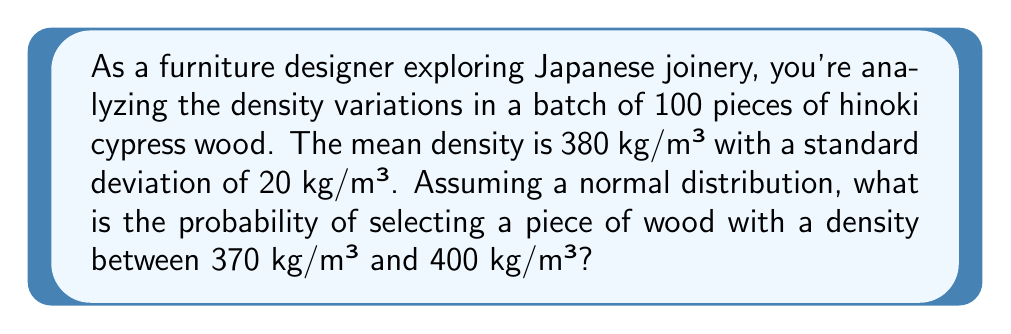Can you solve this math problem? To solve this problem, we'll use the properties of the normal distribution and the concept of z-scores.

Step 1: Calculate the z-scores for the given density values.
Z-score formula: $z = \frac{x - \mu}{\sigma}$
Where $x$ is the value, $\mu$ is the mean, and $\sigma$ is the standard deviation.

For 370 kg/m³: $z_1 = \frac{370 - 380}{20} = -0.5$
For 400 kg/m³: $z_2 = \frac{400 - 380}{20} = 1$

Step 2: Use the standard normal distribution table or a calculator to find the area under the curve between these z-scores.

The probability is equal to the area between $z_1$ and $z_2$.

$P(-0.5 < Z < 1) = P(Z < 1) - P(Z < -0.5)$

Using a standard normal distribution table or calculator:
$P(Z < 1) \approx 0.8413$
$P(Z < -0.5) \approx 0.3085$

Step 3: Calculate the final probability.
$P(-0.5 < Z < 1) = 0.8413 - 0.3085 = 0.5328$

Therefore, the probability of selecting a piece of hinoki cypress wood with a density between 370 kg/m³ and 400 kg/m³ is approximately 0.5328 or 53.28%.
Answer: 0.5328 or 53.28% 